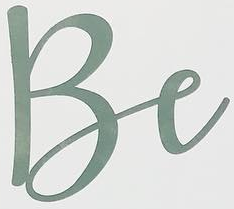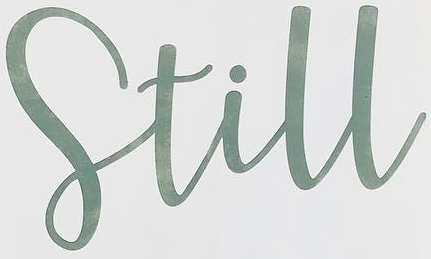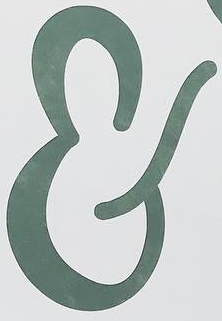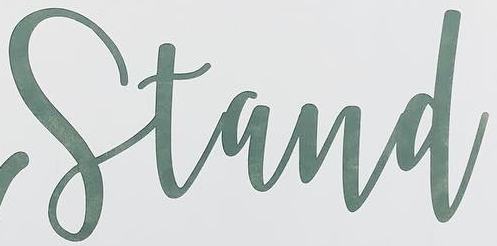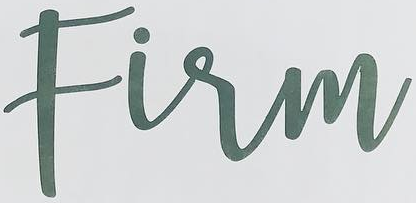What text is displayed in these images sequentially, separated by a semicolon? Be; Still; &; Stand; Firm 